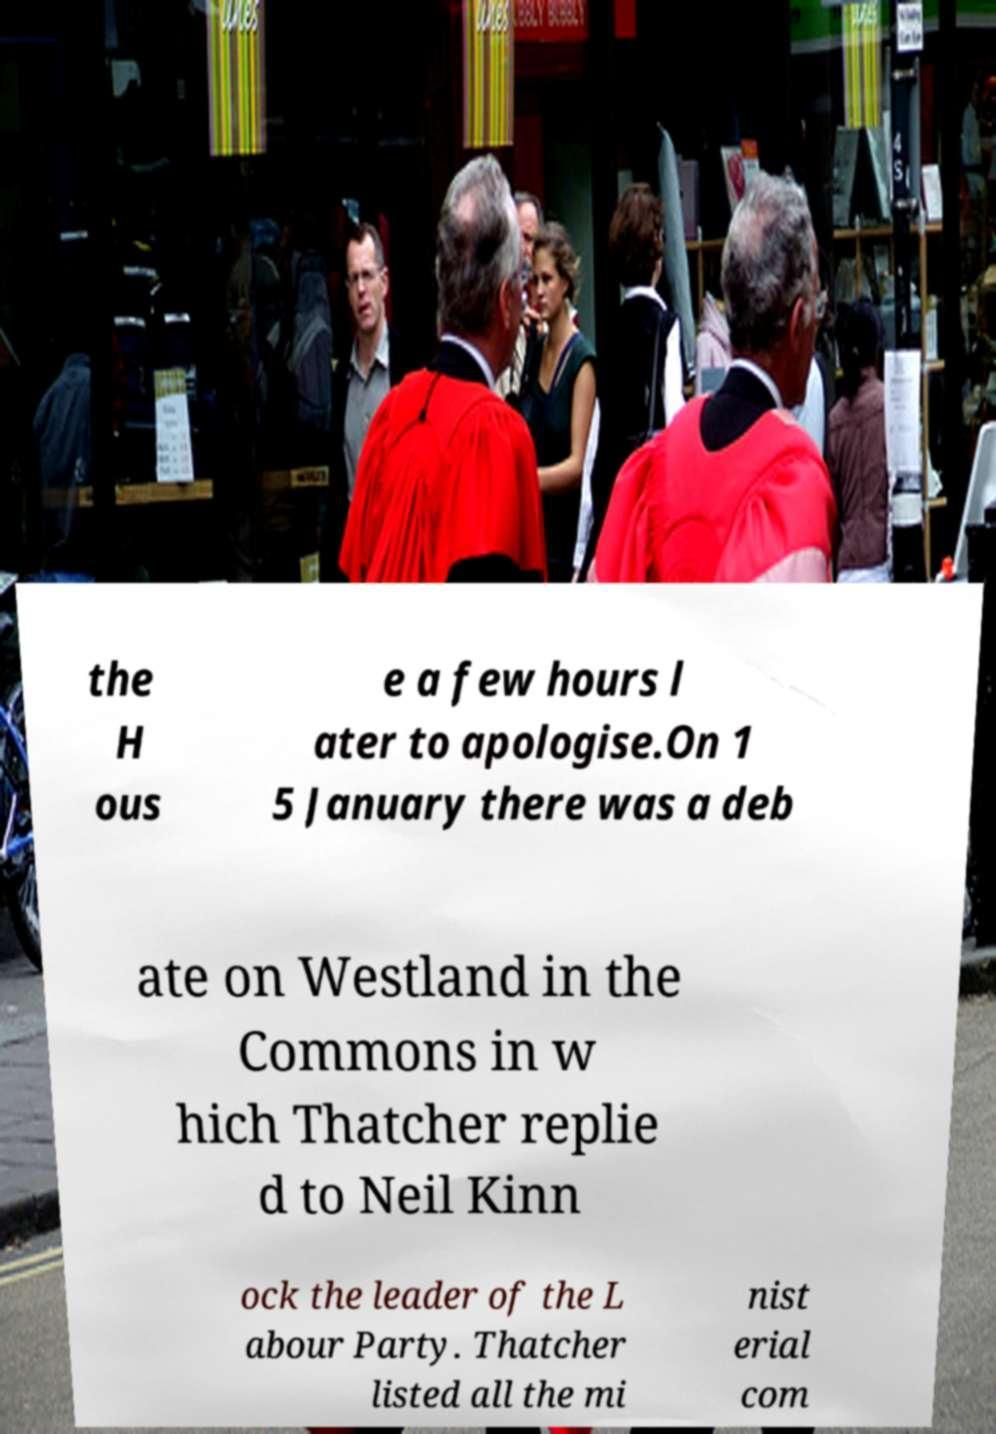Please identify and transcribe the text found in this image. the H ous e a few hours l ater to apologise.On 1 5 January there was a deb ate on Westland in the Commons in w hich Thatcher replie d to Neil Kinn ock the leader of the L abour Party. Thatcher listed all the mi nist erial com 